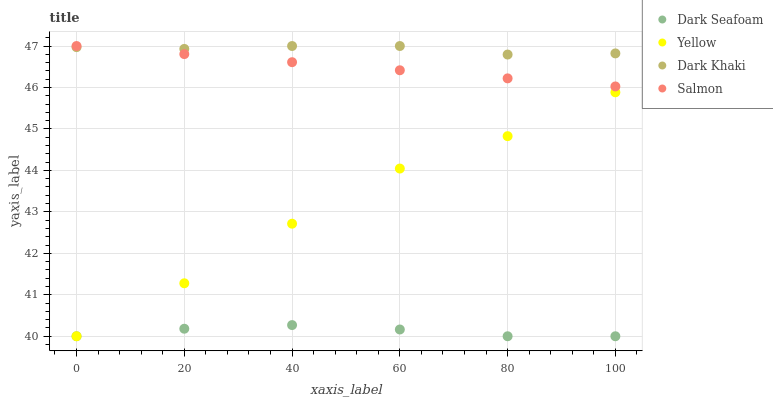Does Dark Seafoam have the minimum area under the curve?
Answer yes or no. Yes. Does Dark Khaki have the maximum area under the curve?
Answer yes or no. Yes. Does Salmon have the minimum area under the curve?
Answer yes or no. No. Does Salmon have the maximum area under the curve?
Answer yes or no. No. Is Salmon the smoothest?
Answer yes or no. Yes. Is Yellow the roughest?
Answer yes or no. Yes. Is Dark Seafoam the smoothest?
Answer yes or no. No. Is Dark Seafoam the roughest?
Answer yes or no. No. Does Dark Seafoam have the lowest value?
Answer yes or no. Yes. Does Salmon have the lowest value?
Answer yes or no. No. Does Salmon have the highest value?
Answer yes or no. Yes. Does Dark Seafoam have the highest value?
Answer yes or no. No. Is Yellow less than Salmon?
Answer yes or no. Yes. Is Salmon greater than Dark Seafoam?
Answer yes or no. Yes. Does Dark Khaki intersect Salmon?
Answer yes or no. Yes. Is Dark Khaki less than Salmon?
Answer yes or no. No. Is Dark Khaki greater than Salmon?
Answer yes or no. No. Does Yellow intersect Salmon?
Answer yes or no. No. 